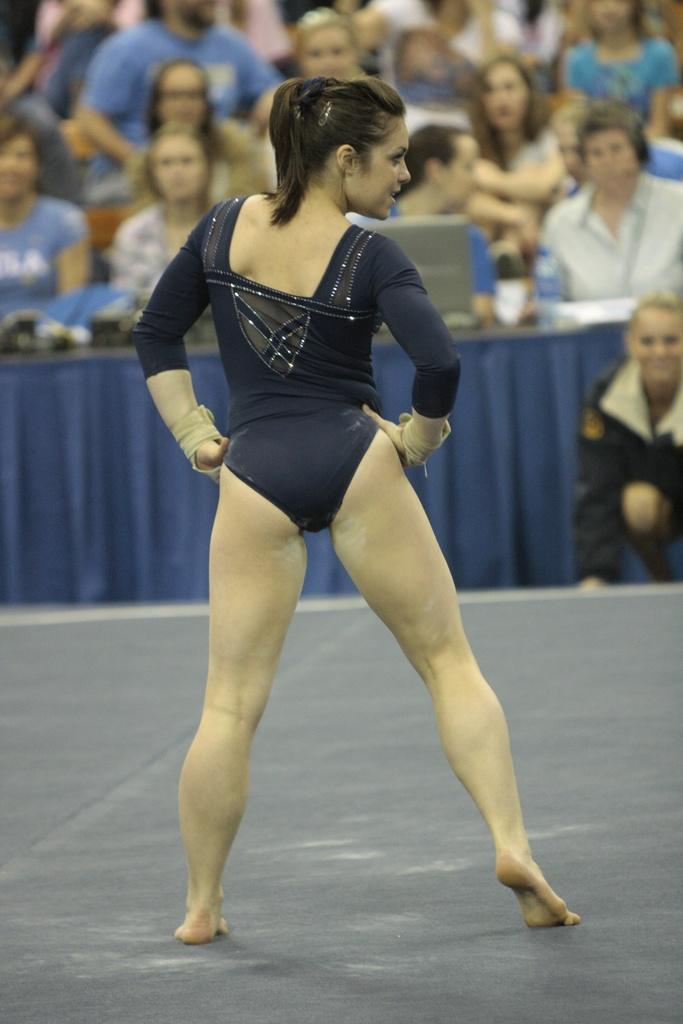What is the person in the image wearing? The person is wearing a navy blue color dress. Can you describe the people in the background of the image? There are people in the background of the image, but their specific features are not mentioned in the facts. What electronic device is visible in the background of the image? A laptop is visible in the background of the image. What else can be seen on the table in the background of the image? There are objects on a table in the background of the image, but their specific details are not mentioned in the facts. What type of flowers are arranged in a line on the table in the image? There are no flowers or lines mentioned in the image; it only includes a person, a navy blue dress, people in the background, a laptop, and objects on a table. 